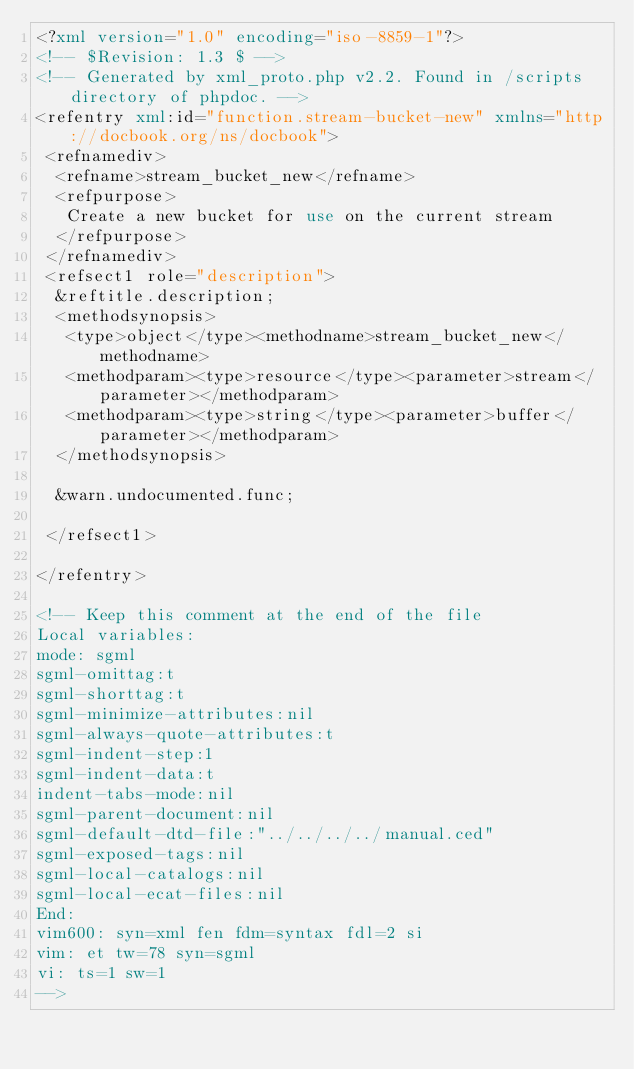Convert code to text. <code><loc_0><loc_0><loc_500><loc_500><_XML_><?xml version="1.0" encoding="iso-8859-1"?>
<!-- $Revision: 1.3 $ -->
<!-- Generated by xml_proto.php v2.2. Found in /scripts directory of phpdoc. -->
<refentry xml:id="function.stream-bucket-new" xmlns="http://docbook.org/ns/docbook">
 <refnamediv>
  <refname>stream_bucket_new</refname>
  <refpurpose>
   Create a new bucket for use on the current stream
  </refpurpose>
 </refnamediv>
 <refsect1 role="description">
  &reftitle.description;
  <methodsynopsis>
   <type>object</type><methodname>stream_bucket_new</methodname>
   <methodparam><type>resource</type><parameter>stream</parameter></methodparam>
   <methodparam><type>string</type><parameter>buffer</parameter></methodparam>
  </methodsynopsis>

  &warn.undocumented.func;

 </refsect1>

</refentry>

<!-- Keep this comment at the end of the file
Local variables:
mode: sgml
sgml-omittag:t
sgml-shorttag:t
sgml-minimize-attributes:nil
sgml-always-quote-attributes:t
sgml-indent-step:1
sgml-indent-data:t
indent-tabs-mode:nil
sgml-parent-document:nil
sgml-default-dtd-file:"../../../../manual.ced"
sgml-exposed-tags:nil
sgml-local-catalogs:nil
sgml-local-ecat-files:nil
End:
vim600: syn=xml fen fdm=syntax fdl=2 si
vim: et tw=78 syn=sgml
vi: ts=1 sw=1
-->
</code> 